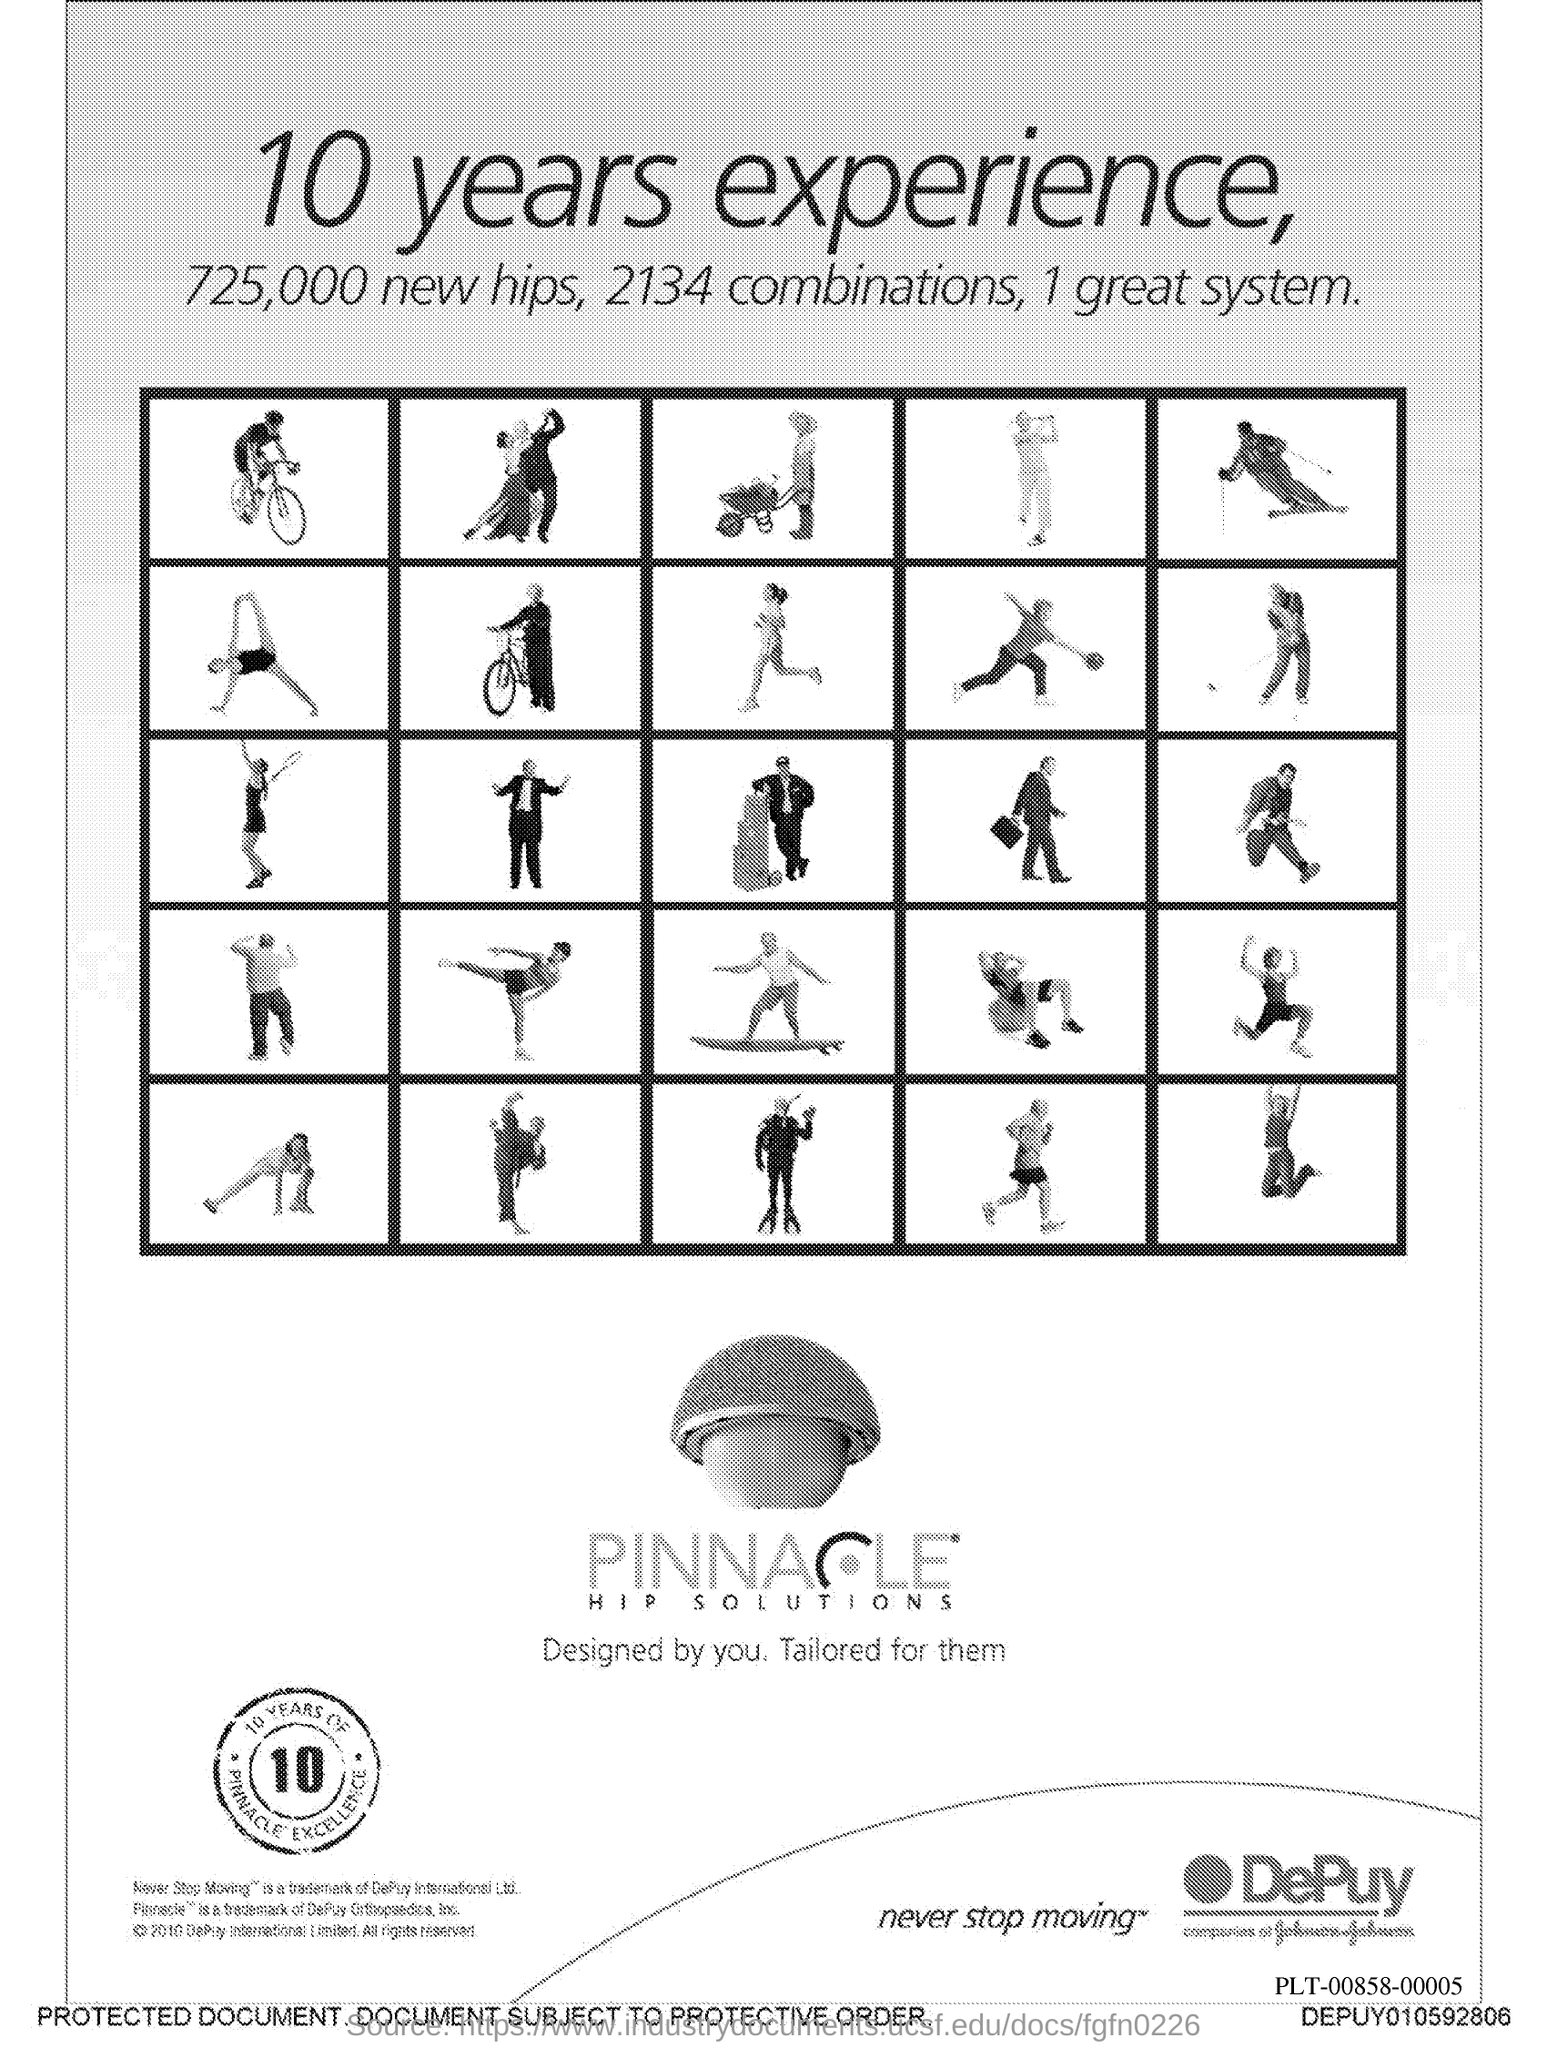What is the total number of new hips?
Keep it short and to the point. 725,000. 